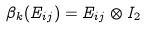<formula> <loc_0><loc_0><loc_500><loc_500>\beta _ { k } ( E _ { i j } ) = E _ { i j } \otimes I _ { 2 }</formula> 